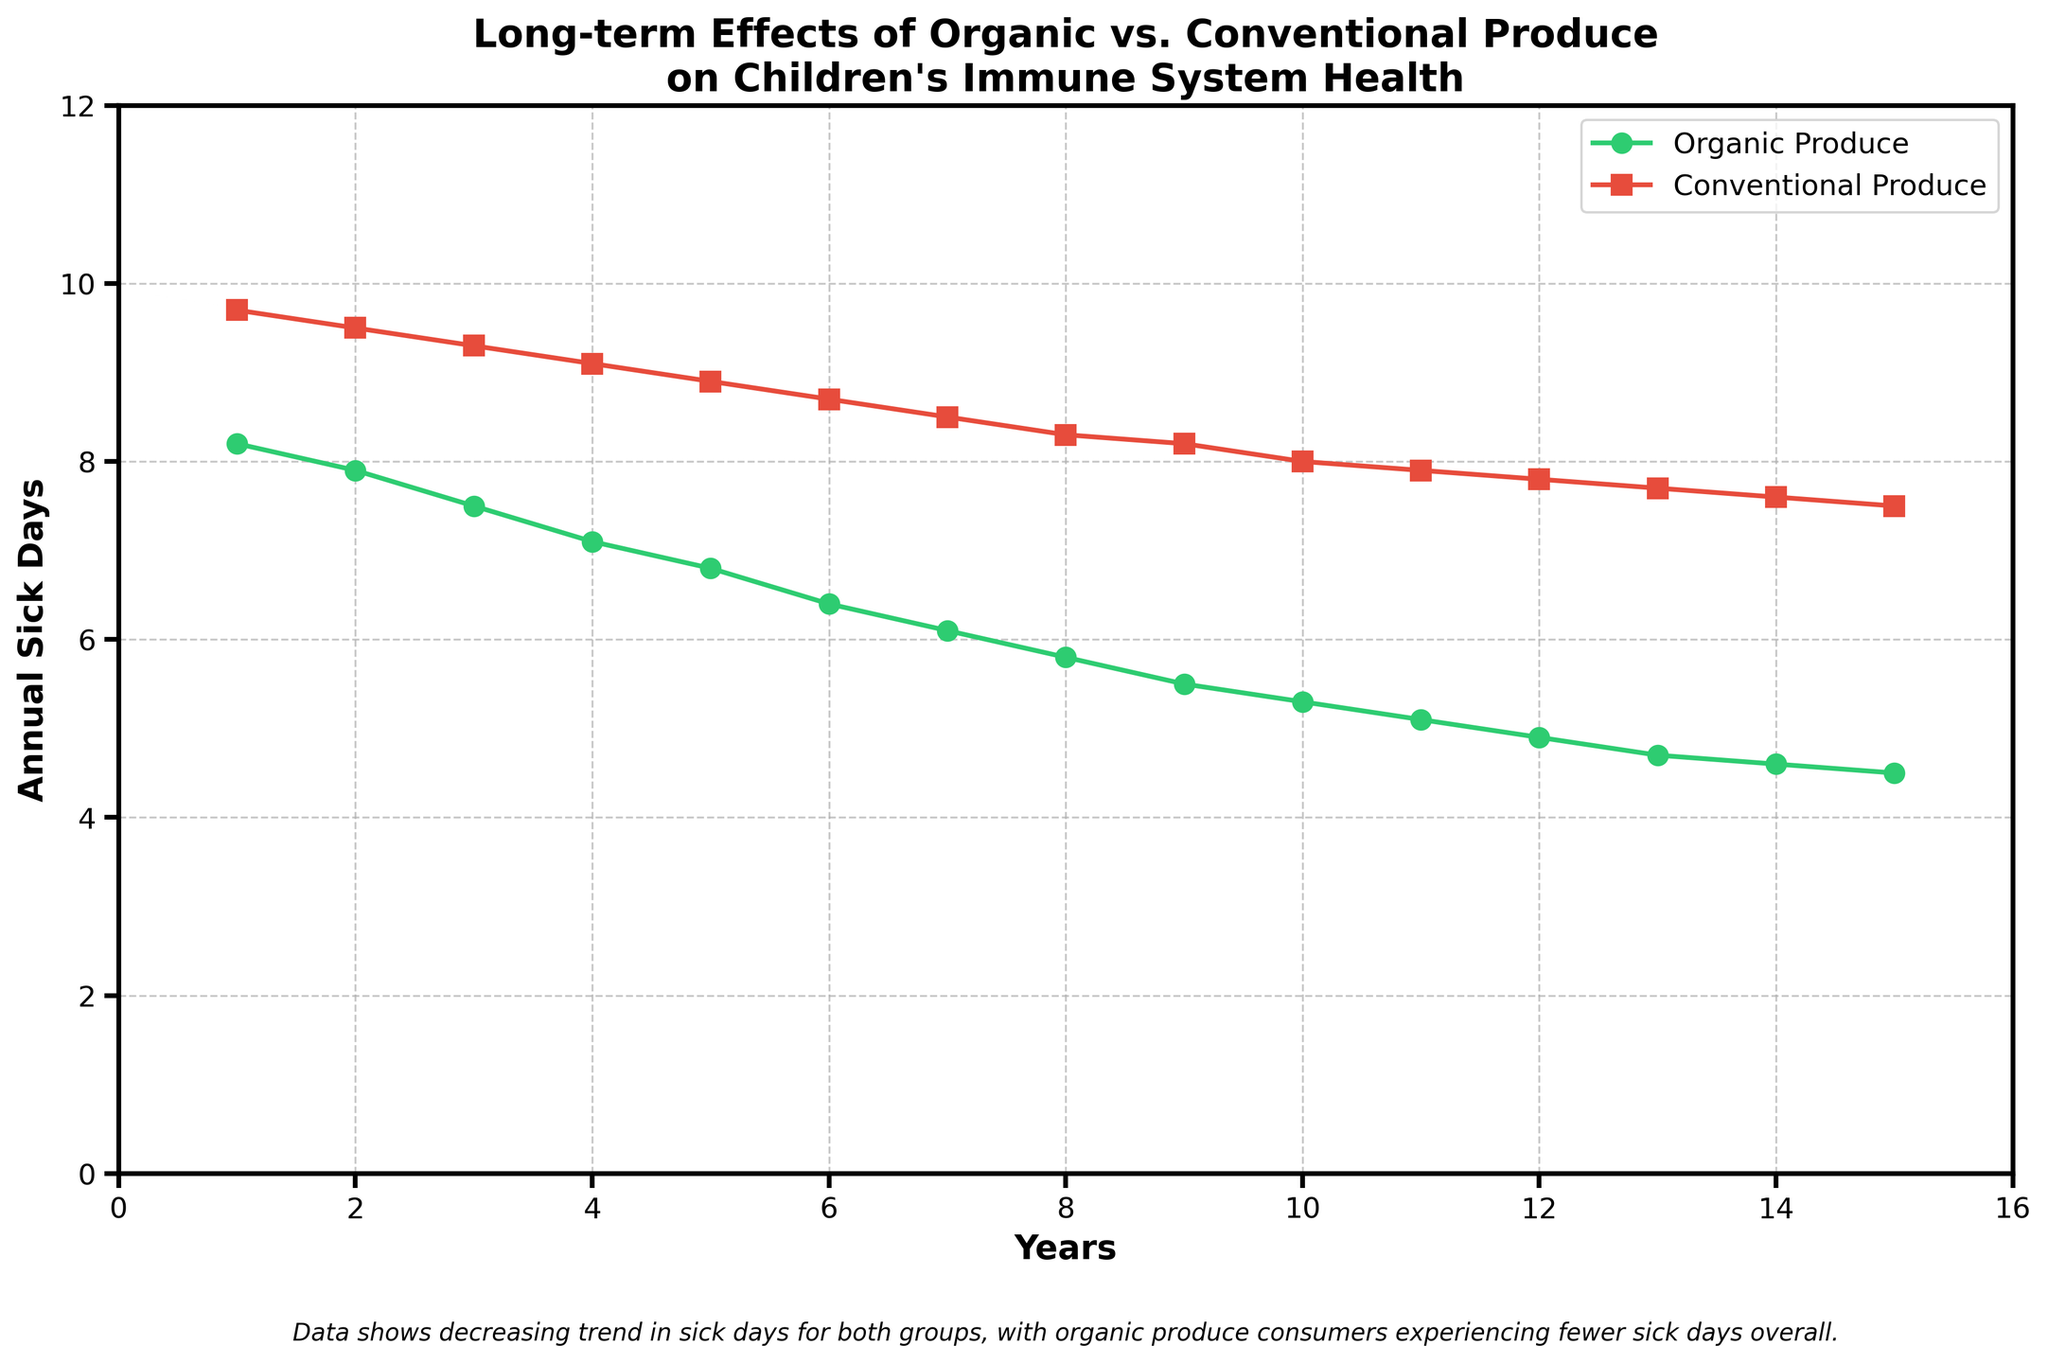What is the trend in the number of annual sick days for children consuming organic produce over the 15 years? The line representing organic produce consumption shows a consistent downward trend from 8.2 sick days in Year 1 to 4.5 sick days in Year 15. This suggests that the number of annual sick days for children consuming organic produce decreases over time.
Answer: Decreasing How do the annual sick days of children consuming organic produce compare to those consuming conventional produce in Year 10? In Year 10, children consuming organic produce have 5.3 annual sick days, whereas those consuming conventional produce have 8.0 annual sick days.
Answer: Organic: 5.3, Conventional: 8.0 What is the average annual sick days for children consuming organic produce from Year 1 to Year 5? Sum the values for organic produce from Year 1 to Year 5 (8.2 + 7.9 + 7.5 + 7.1 + 6.8) which equals 37.5. The average is 37.5/5.
Answer: 7.5 By how many days do annual sick days decrease from Year 1 to Year 15 for children consuming conventional produce? The number of annual sick days for conventional produce decreases from 9.7 in Year 1 to 7.5 in Year 15. The decrease is calculated as 9.7 - 7.5.
Answer: 2.2 days Which group experiences a lower number of annual sick days consistently, and by what visual attribute can you tell? The group consuming organic produce consistently experiences fewer annual sick days, which can be inferred from the green line (organic produce) being consistently lower than the red line (conventional produce) across all years.
Answer: Organic Produce (Green Line) What is the difference in the number of annual sick days between the two groups in Year 7? In Year 7, the sick days for organic produce consumption are 6.1, and for conventional produce consumption are 8.5. Subtracting these values gives 8.5 - 6.1.
Answer: 2.4 days During which year is the disparity between annual sick days for organic and conventional produce the greatest? The disparity is greatest where the vertical distance between the two lines is largest. In Year 12, annual sick days for organic produce are 4.9, and for conventional produce, they are 7.8, a difference of 2.9.
Answer: Year 12 What is the median annual sick days for children consuming conventional produce over 15 years? List the values for conventional produce (9.7, 9.5, 9.3, 9.1, 8.9, 8.7, 8.5, 8.3, 8.2, 8.0, 7.9, 7.8, 7.7, 7.6, 7.5) and find the middle value. The median value is 8.3.
Answer: 8.3 What is the overall trend for both groups from Year 1 to Year 15? Both lines on the chart show a downward trend, indicating that the number of annual sick days decreases over the years for both organic and conventional produce consumption groups.
Answer: Decreasing How many fewer sick days do children consuming organic produce experience compared to those consuming conventional produce on average over the 15 years? Compute the differences for each year, then find the average of those differences: [(9.7 - 8.2) + (9.5 - 7.9) + (9.3 - 7.5) + (9.1 - 7.1) + (8.9 - 6.8) + (8.7 - 6.4) + (8.5 - 6.1) + (8.3 - 5.8) + (8.2 - 5.5) + (8.0 - 5.3) + (7.9 - 5.1) + (7.8 - 4.9) + (7.7 - 4.7) + (7.6 - 4.6) + (7.5 - 4.5)] / 15 = 2.5.
Answer: 2.5 days 